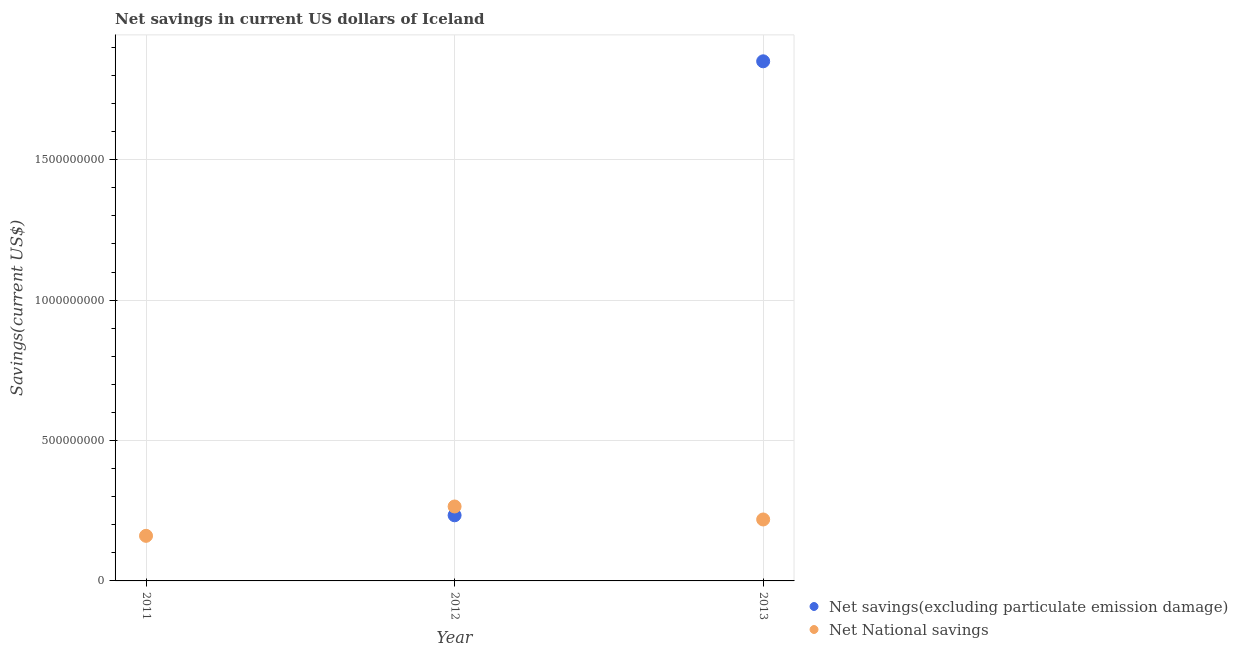Is the number of dotlines equal to the number of legend labels?
Your response must be concise. No. What is the net national savings in 2012?
Make the answer very short. 2.65e+08. Across all years, what is the maximum net savings(excluding particulate emission damage)?
Ensure brevity in your answer.  1.85e+09. Across all years, what is the minimum net national savings?
Ensure brevity in your answer.  1.61e+08. In which year was the net national savings maximum?
Ensure brevity in your answer.  2012. What is the total net savings(excluding particulate emission damage) in the graph?
Offer a terse response. 2.08e+09. What is the difference between the net savings(excluding particulate emission damage) in 2012 and that in 2013?
Make the answer very short. -1.62e+09. What is the difference between the net savings(excluding particulate emission damage) in 2011 and the net national savings in 2012?
Your response must be concise. -2.65e+08. What is the average net national savings per year?
Your answer should be very brief. 2.15e+08. In the year 2012, what is the difference between the net savings(excluding particulate emission damage) and net national savings?
Ensure brevity in your answer.  -3.14e+07. In how many years, is the net national savings greater than 800000000 US$?
Ensure brevity in your answer.  0. What is the ratio of the net national savings in 2012 to that in 2013?
Provide a short and direct response. 1.21. Is the net savings(excluding particulate emission damage) in 2012 less than that in 2013?
Make the answer very short. Yes. Is the difference between the net savings(excluding particulate emission damage) in 2012 and 2013 greater than the difference between the net national savings in 2012 and 2013?
Provide a short and direct response. No. What is the difference between the highest and the second highest net national savings?
Provide a short and direct response. 4.63e+07. What is the difference between the highest and the lowest net savings(excluding particulate emission damage)?
Offer a terse response. 1.85e+09. In how many years, is the net savings(excluding particulate emission damage) greater than the average net savings(excluding particulate emission damage) taken over all years?
Keep it short and to the point. 1. Is the net national savings strictly less than the net savings(excluding particulate emission damage) over the years?
Offer a terse response. No. How many dotlines are there?
Your response must be concise. 2. How many years are there in the graph?
Your response must be concise. 3. Does the graph contain grids?
Give a very brief answer. Yes. Where does the legend appear in the graph?
Provide a succinct answer. Bottom right. What is the title of the graph?
Your answer should be compact. Net savings in current US dollars of Iceland. What is the label or title of the X-axis?
Provide a succinct answer. Year. What is the label or title of the Y-axis?
Offer a very short reply. Savings(current US$). What is the Savings(current US$) in Net National savings in 2011?
Offer a terse response. 1.61e+08. What is the Savings(current US$) of Net savings(excluding particulate emission damage) in 2012?
Keep it short and to the point. 2.34e+08. What is the Savings(current US$) of Net National savings in 2012?
Keep it short and to the point. 2.65e+08. What is the Savings(current US$) in Net savings(excluding particulate emission damage) in 2013?
Make the answer very short. 1.85e+09. What is the Savings(current US$) in Net National savings in 2013?
Your response must be concise. 2.19e+08. Across all years, what is the maximum Savings(current US$) in Net savings(excluding particulate emission damage)?
Provide a succinct answer. 1.85e+09. Across all years, what is the maximum Savings(current US$) of Net National savings?
Ensure brevity in your answer.  2.65e+08. Across all years, what is the minimum Savings(current US$) in Net savings(excluding particulate emission damage)?
Your answer should be compact. 0. Across all years, what is the minimum Savings(current US$) in Net National savings?
Give a very brief answer. 1.61e+08. What is the total Savings(current US$) in Net savings(excluding particulate emission damage) in the graph?
Ensure brevity in your answer.  2.08e+09. What is the total Savings(current US$) in Net National savings in the graph?
Give a very brief answer. 6.44e+08. What is the difference between the Savings(current US$) of Net National savings in 2011 and that in 2012?
Your response must be concise. -1.05e+08. What is the difference between the Savings(current US$) of Net National savings in 2011 and that in 2013?
Offer a terse response. -5.82e+07. What is the difference between the Savings(current US$) in Net savings(excluding particulate emission damage) in 2012 and that in 2013?
Your answer should be compact. -1.62e+09. What is the difference between the Savings(current US$) in Net National savings in 2012 and that in 2013?
Provide a succinct answer. 4.63e+07. What is the difference between the Savings(current US$) in Net savings(excluding particulate emission damage) in 2012 and the Savings(current US$) in Net National savings in 2013?
Your answer should be compact. 1.49e+07. What is the average Savings(current US$) of Net savings(excluding particulate emission damage) per year?
Provide a short and direct response. 6.95e+08. What is the average Savings(current US$) in Net National savings per year?
Give a very brief answer. 2.15e+08. In the year 2012, what is the difference between the Savings(current US$) of Net savings(excluding particulate emission damage) and Savings(current US$) of Net National savings?
Offer a very short reply. -3.14e+07. In the year 2013, what is the difference between the Savings(current US$) of Net savings(excluding particulate emission damage) and Savings(current US$) of Net National savings?
Provide a short and direct response. 1.63e+09. What is the ratio of the Savings(current US$) of Net National savings in 2011 to that in 2012?
Your response must be concise. 0.61. What is the ratio of the Savings(current US$) in Net National savings in 2011 to that in 2013?
Give a very brief answer. 0.73. What is the ratio of the Savings(current US$) of Net savings(excluding particulate emission damage) in 2012 to that in 2013?
Give a very brief answer. 0.13. What is the ratio of the Savings(current US$) of Net National savings in 2012 to that in 2013?
Offer a terse response. 1.21. What is the difference between the highest and the second highest Savings(current US$) in Net National savings?
Ensure brevity in your answer.  4.63e+07. What is the difference between the highest and the lowest Savings(current US$) in Net savings(excluding particulate emission damage)?
Ensure brevity in your answer.  1.85e+09. What is the difference between the highest and the lowest Savings(current US$) in Net National savings?
Give a very brief answer. 1.05e+08. 